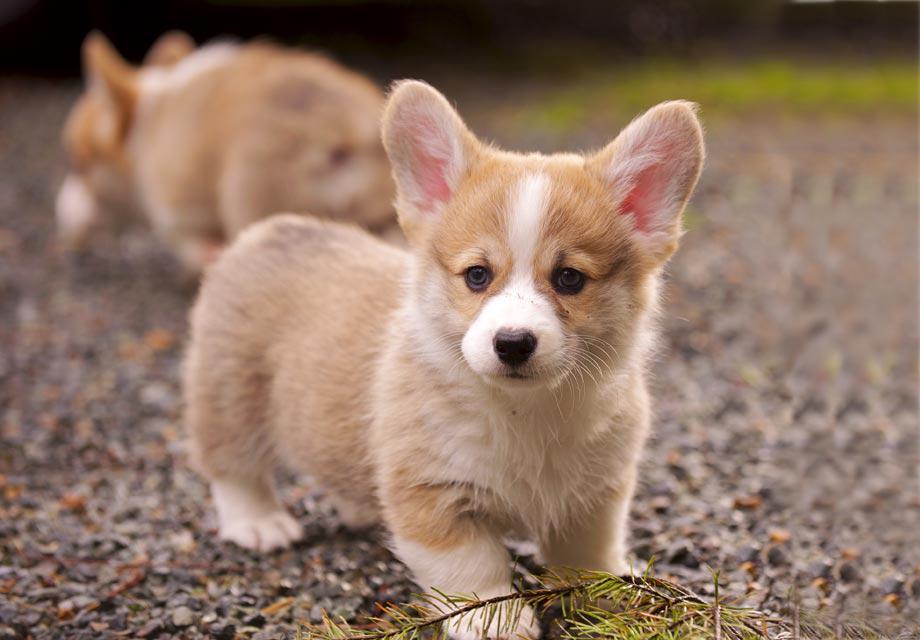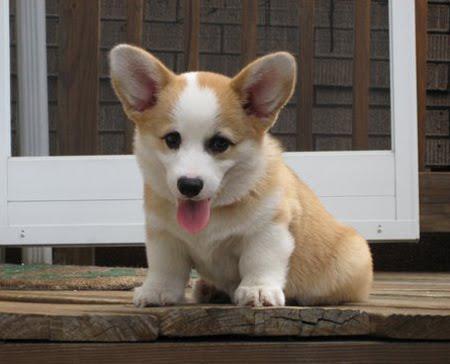The first image is the image on the left, the second image is the image on the right. For the images displayed, is the sentence "An image includes a corgi pup with one ear upright and the ear on the left flopping forward." factually correct? Answer yes or no. No. The first image is the image on the left, the second image is the image on the right. For the images displayed, is the sentence "There's exactly two dogs in the left image." factually correct? Answer yes or no. Yes. The first image is the image on the left, the second image is the image on the right. Given the left and right images, does the statement "An image shows at least three similarly sized dogs posed in a row." hold true? Answer yes or no. No. 